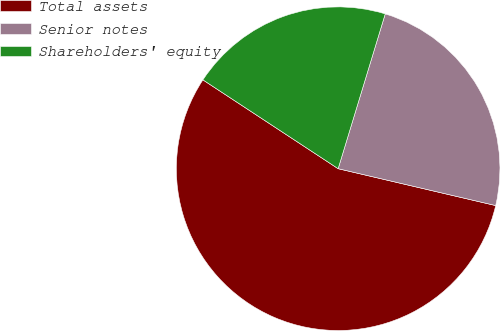<chart> <loc_0><loc_0><loc_500><loc_500><pie_chart><fcel>Total assets<fcel>Senior notes<fcel>Shareholders' equity<nl><fcel>55.59%<fcel>23.96%<fcel>20.45%<nl></chart> 